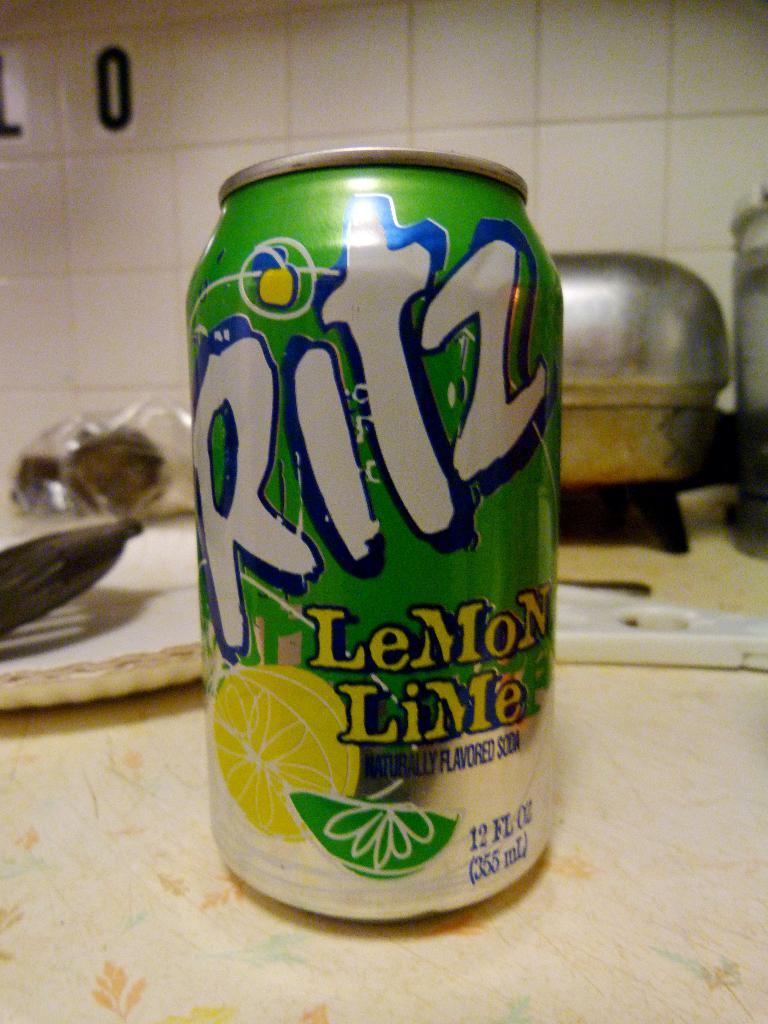What is the main object in the image? There is a tin in the image. What else can be seen on the table in the image? There are disposable plates and utensils on the table in the image. What type of surface is visible on the wall in the background of the image? There are tiles on the wall in the background of the image. Where is the meeting taking place in the image? There is no meeting taking place in the image; it only shows a tin, disposable plates, utensils, and tiles on the wall. 